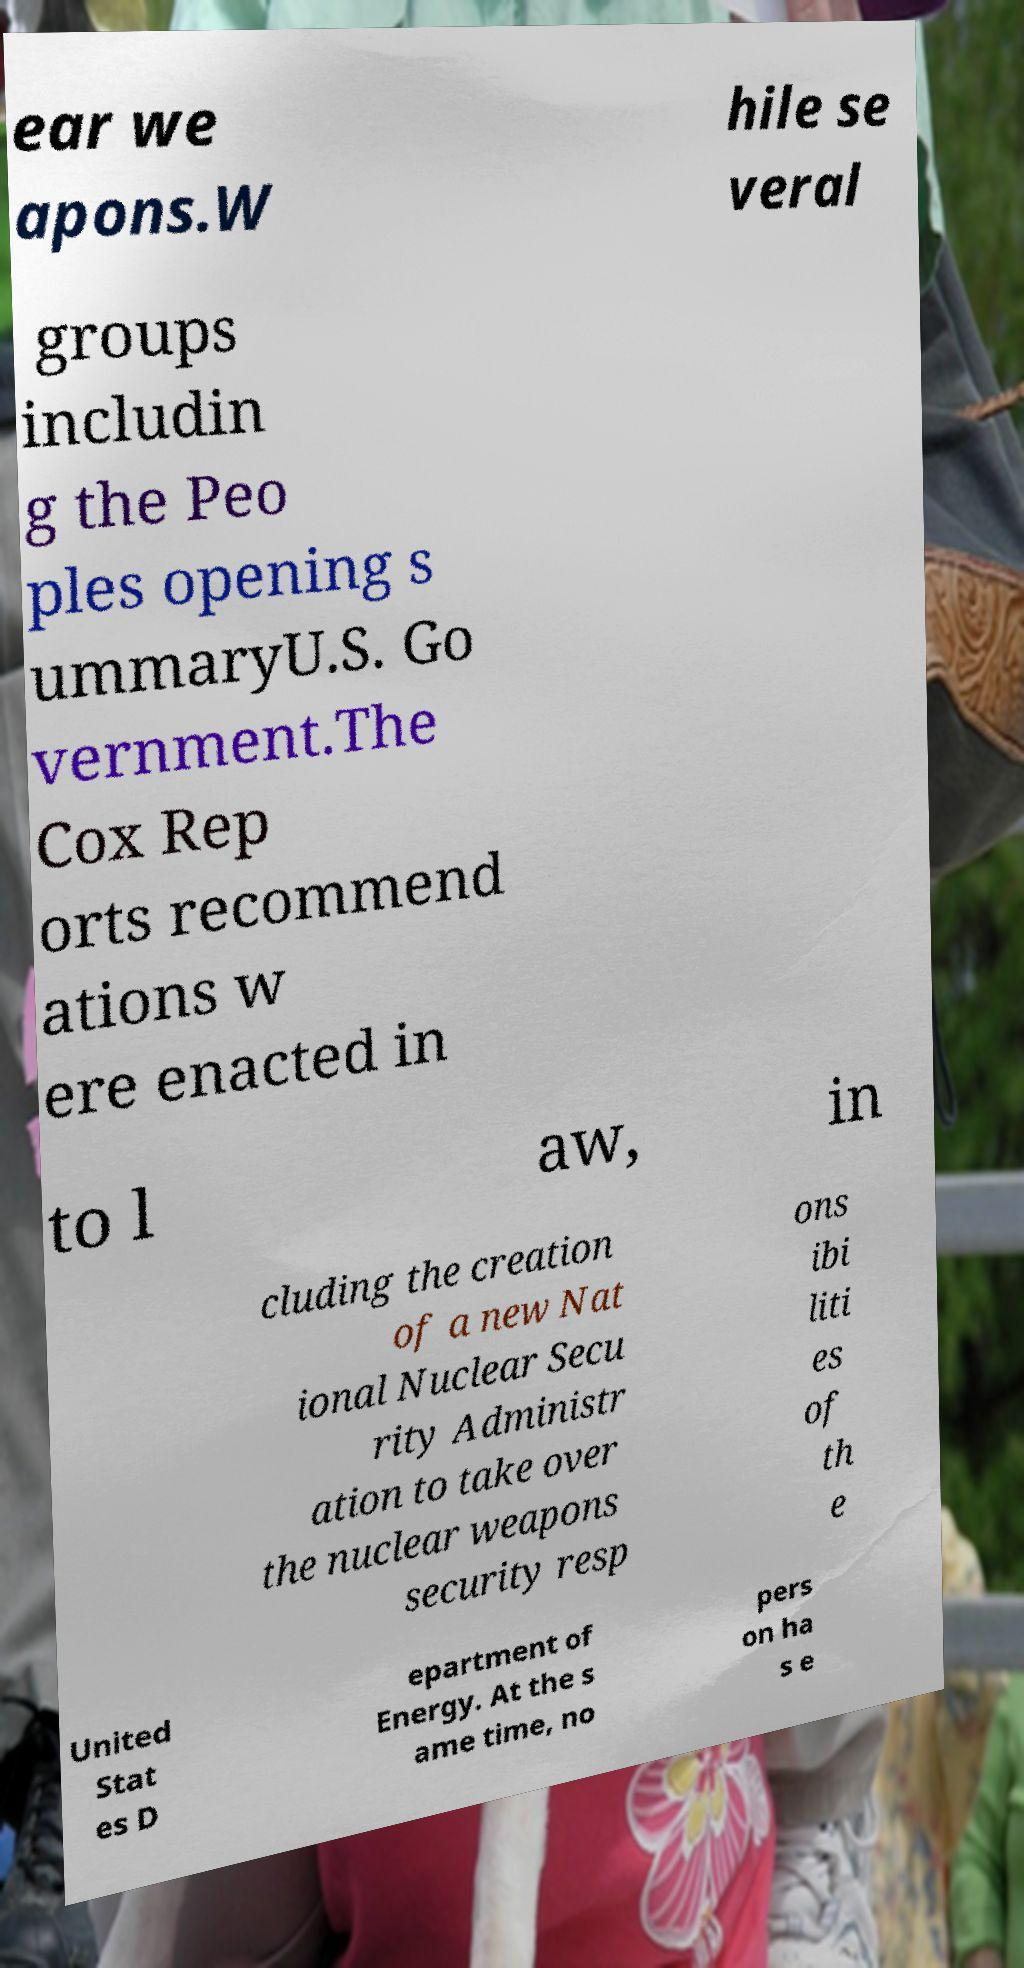Can you read and provide the text displayed in the image?This photo seems to have some interesting text. Can you extract and type it out for me? ear we apons.W hile se veral groups includin g the Peo ples opening s ummaryU.S. Go vernment.The Cox Rep orts recommend ations w ere enacted in to l aw, in cluding the creation of a new Nat ional Nuclear Secu rity Administr ation to take over the nuclear weapons security resp ons ibi liti es of th e United Stat es D epartment of Energy. At the s ame time, no pers on ha s e 